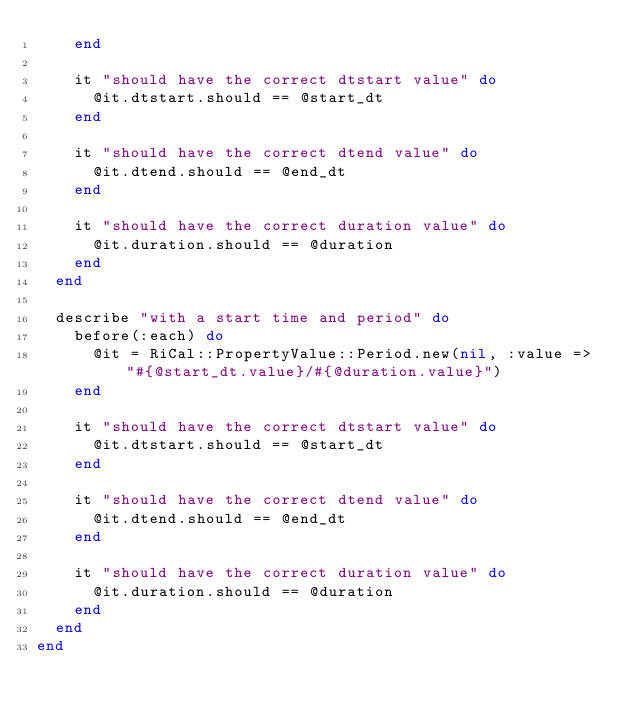<code> <loc_0><loc_0><loc_500><loc_500><_Ruby_>    end
    
    it "should have the correct dtstart value" do
      @it.dtstart.should == @start_dt
    end
    
    it "should have the correct dtend value" do
      @it.dtend.should == @end_dt
    end
    
    it "should have the correct duration value" do
      @it.duration.should == @duration
    end
  end
  
  describe "with a start time and period" do
    before(:each) do
      @it = RiCal::PropertyValue::Period.new(nil, :value => "#{@start_dt.value}/#{@duration.value}")
    end
    
    it "should have the correct dtstart value" do
      @it.dtstart.should == @start_dt
    end
    
    it "should have the correct dtend value" do
      @it.dtend.should == @end_dt
    end
    
    it "should have the correct duration value" do
      @it.duration.should == @duration
    end
  end
end</code> 